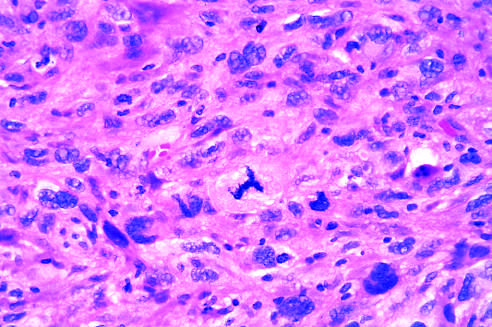does the graft damage have an abnormal tripolar spindle?
Answer the question using a single word or phrase. No 